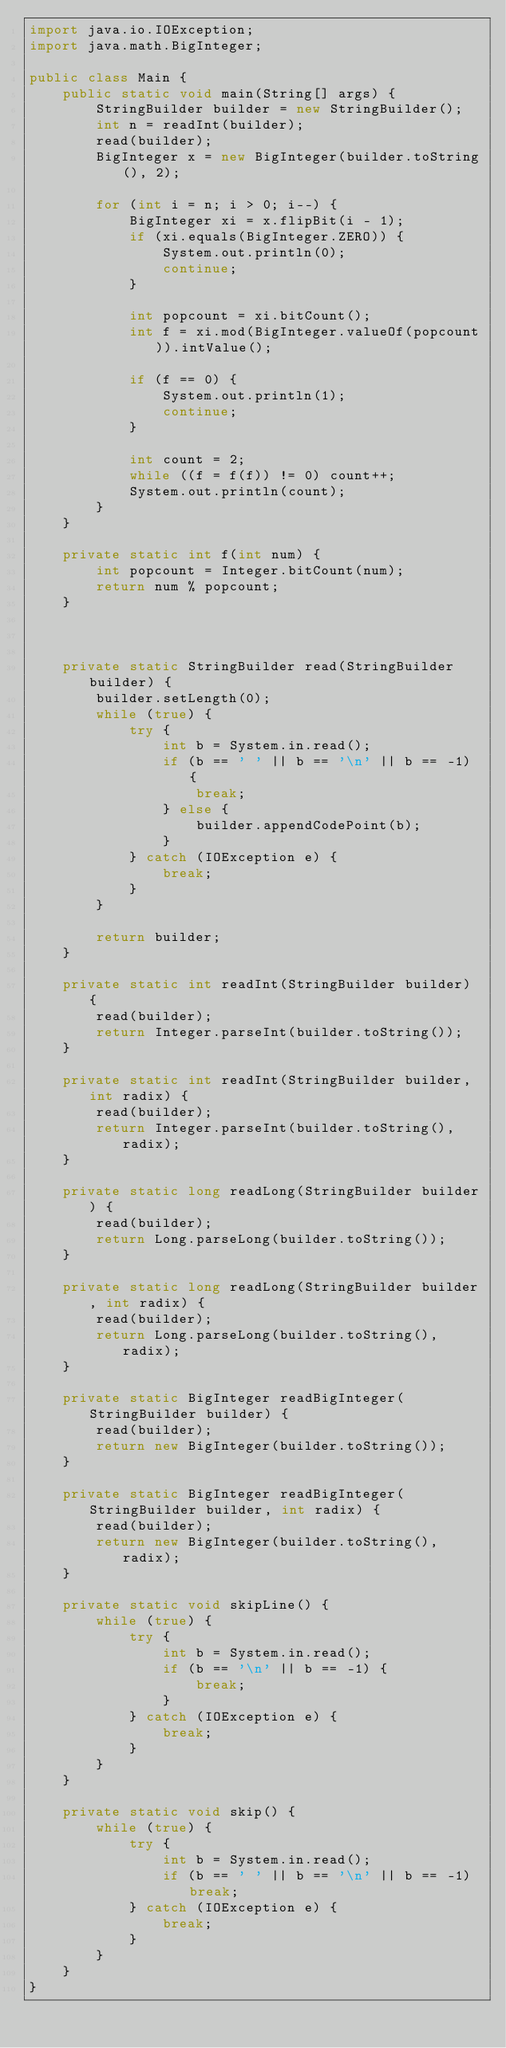Convert code to text. <code><loc_0><loc_0><loc_500><loc_500><_Java_>import java.io.IOException;
import java.math.BigInteger;

public class Main {
    public static void main(String[] args) {
        StringBuilder builder = new StringBuilder();
        int n = readInt(builder);
        read(builder);
        BigInteger x = new BigInteger(builder.toString(), 2);

        for (int i = n; i > 0; i--) {
            BigInteger xi = x.flipBit(i - 1);
            if (xi.equals(BigInteger.ZERO)) {
                System.out.println(0);
                continue;
            }

            int popcount = xi.bitCount();
            int f = xi.mod(BigInteger.valueOf(popcount)).intValue();

            if (f == 0) {
                System.out.println(1);
                continue;
            }

            int count = 2;
            while ((f = f(f)) != 0) count++;
            System.out.println(count);
        }
    }

    private static int f(int num) {
        int popcount = Integer.bitCount(num);
        return num % popcount;
    }



    private static StringBuilder read(StringBuilder builder) {
        builder.setLength(0);
        while (true) {
            try {
                int b = System.in.read();
                if (b == ' ' || b == '\n' || b == -1) {
                    break;
                } else {
                    builder.appendCodePoint(b);
                }
            } catch (IOException e) {
                break;
            }
        }

        return builder;
    }

    private static int readInt(StringBuilder builder) {
        read(builder);
        return Integer.parseInt(builder.toString());
    }

    private static int readInt(StringBuilder builder, int radix) {
        read(builder);
        return Integer.parseInt(builder.toString(), radix);
    }

    private static long readLong(StringBuilder builder) {
        read(builder);
        return Long.parseLong(builder.toString());
    }

    private static long readLong(StringBuilder builder, int radix) {
        read(builder);
        return Long.parseLong(builder.toString(), radix);
    }

    private static BigInteger readBigInteger(StringBuilder builder) {
        read(builder);
        return new BigInteger(builder.toString());
    }

    private static BigInteger readBigInteger(StringBuilder builder, int radix) {
        read(builder);
        return new BigInteger(builder.toString(), radix);
    }

    private static void skipLine() {
        while (true) {
            try {
                int b = System.in.read();
                if (b == '\n' || b == -1) {
                    break;
                }
            } catch (IOException e) {
                break;
            }
        }
    }

    private static void skip() {
        while (true) {
            try {
                int b = System.in.read();
                if (b == ' ' || b == '\n' || b == -1) break;
            } catch (IOException e) {
                break;
            }
        }
    }
}
</code> 